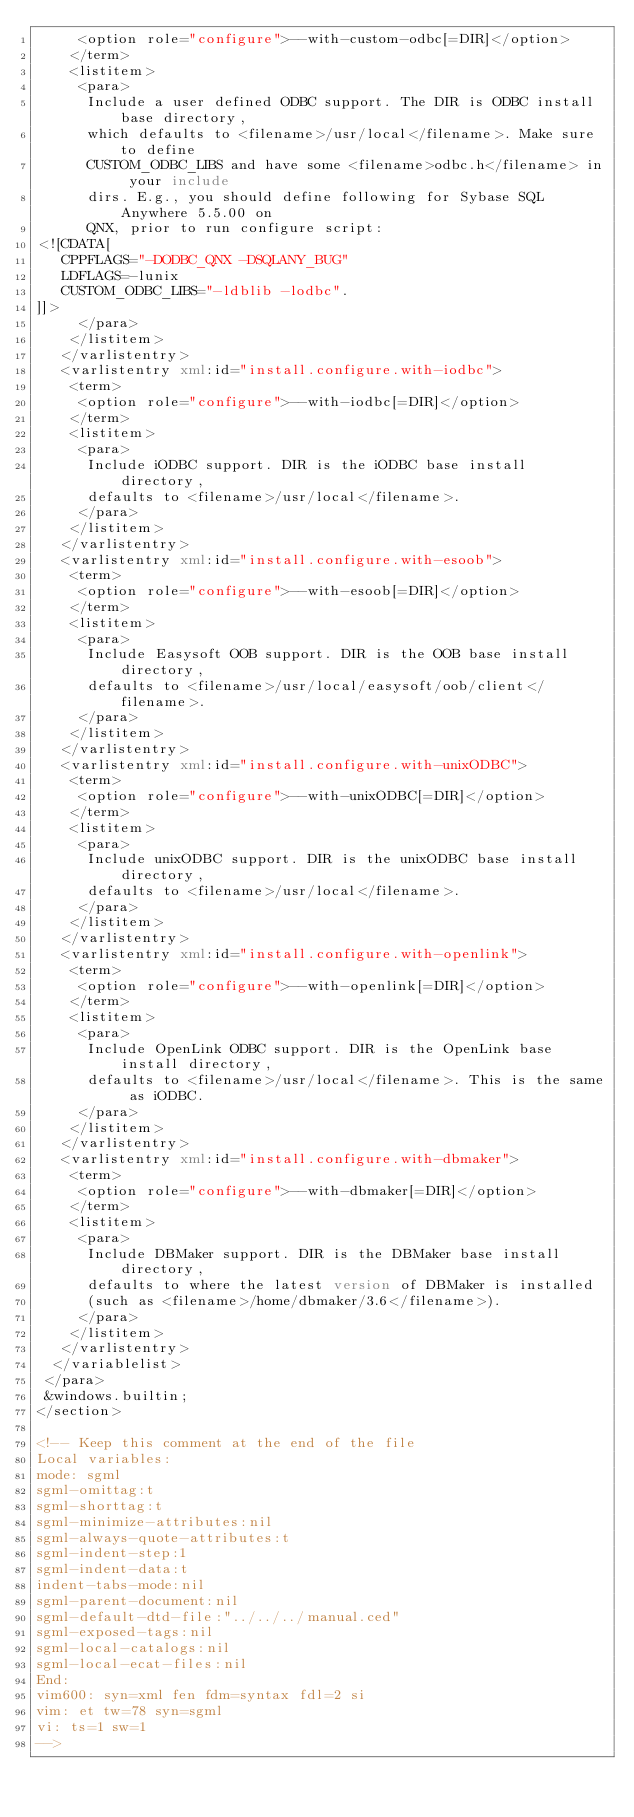Convert code to text. <code><loc_0><loc_0><loc_500><loc_500><_XML_>     <option role="configure">--with-custom-odbc[=DIR]</option>
    </term>
    <listitem>
     <para>
      Include a user defined ODBC support. The DIR is ODBC install base directory, 
      which defaults to <filename>/usr/local</filename>. Make sure to define
      CUSTOM_ODBC_LIBS and have some <filename>odbc.h</filename> in your include
      dirs. E.g., you should define following for Sybase SQL Anywhere 5.5.00 on
      QNX, prior to run configure script:
<![CDATA[
   CPPFLAGS="-DODBC_QNX -DSQLANY_BUG"
   LDFLAGS=-lunix
   CUSTOM_ODBC_LIBS="-ldblib -lodbc".
]]> 
     </para>
    </listitem>
   </varlistentry>
   <varlistentry xml:id="install.configure.with-iodbc">
    <term>
     <option role="configure">--with-iodbc[=DIR]</option>
    </term>
    <listitem>
     <para>
      Include iODBC support. DIR is the iODBC base install directory, 
      defaults to <filename>/usr/local</filename>.
     </para>
    </listitem>
   </varlistentry>
   <varlistentry xml:id="install.configure.with-esoob">
    <term>
     <option role="configure">--with-esoob[=DIR]</option>
    </term>
    <listitem>
     <para>
      Include Easysoft OOB support. DIR is the OOB base install directory, 
      defaults to <filename>/usr/local/easysoft/oob/client</filename>.
     </para>
    </listitem>
   </varlistentry>
   <varlistentry xml:id="install.configure.with-unixODBC">
    <term>
     <option role="configure">--with-unixODBC[=DIR]</option>
    </term>
    <listitem>
     <para>
      Include unixODBC support. DIR is the unixODBC base install directory, 
      defaults to <filename>/usr/local</filename>.
     </para>
    </listitem>
   </varlistentry>
   <varlistentry xml:id="install.configure.with-openlink">
    <term>
     <option role="configure">--with-openlink[=DIR]</option>
    </term>
    <listitem>
     <para>
      Include OpenLink ODBC support. DIR is the OpenLink base install directory, 
      defaults to <filename>/usr/local</filename>. This is the same as iODBC.
     </para>
    </listitem>
   </varlistentry>
   <varlistentry xml:id="install.configure.with-dbmaker">
    <term>
     <option role="configure">--with-dbmaker[=DIR]</option>
    </term>
    <listitem>
     <para>
      Include DBMaker support. DIR is the DBMaker base install directory, 
      defaults to where the latest version of DBMaker is installed 
      (such as <filename>/home/dbmaker/3.6</filename>).
     </para>
    </listitem>
   </varlistentry>
  </variablelist>
 </para>
 &windows.builtin;
</section>

<!-- Keep this comment at the end of the file
Local variables:
mode: sgml
sgml-omittag:t
sgml-shorttag:t
sgml-minimize-attributes:nil
sgml-always-quote-attributes:t
sgml-indent-step:1
sgml-indent-data:t
indent-tabs-mode:nil
sgml-parent-document:nil
sgml-default-dtd-file:"../../../manual.ced"
sgml-exposed-tags:nil
sgml-local-catalogs:nil
sgml-local-ecat-files:nil
End:
vim600: syn=xml fen fdm=syntax fdl=2 si
vim: et tw=78 syn=sgml
vi: ts=1 sw=1
-->
</code> 